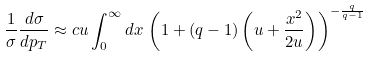Convert formula to latex. <formula><loc_0><loc_0><loc_500><loc_500>\frac { 1 } { \sigma } \frac { d \sigma } { d p _ { T } } \approx c u \int _ { 0 } ^ { \infty } d x \, \left ( 1 + ( q - 1 ) \left ( u + \frac { x ^ { 2 } } { 2 u } \right ) \right ) ^ { - \frac { q } { q - 1 } }</formula> 